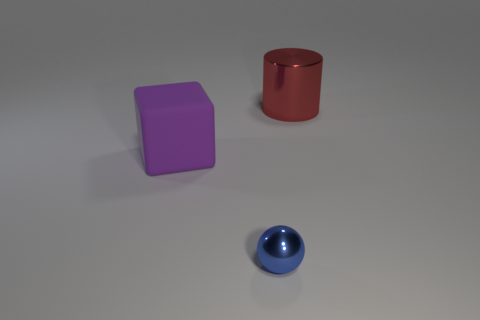Add 1 large blue objects. How many objects exist? 4 Subtract all balls. How many objects are left? 2 Subtract 0 yellow balls. How many objects are left? 3 Subtract all big cylinders. Subtract all balls. How many objects are left? 1 Add 1 tiny blue metal things. How many tiny blue metal things are left? 2 Add 1 blocks. How many blocks exist? 2 